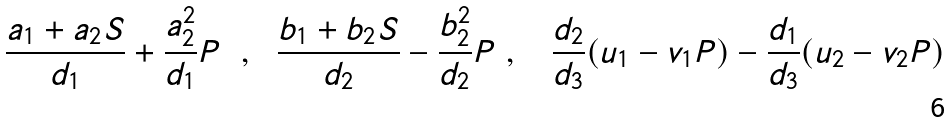<formula> <loc_0><loc_0><loc_500><loc_500>\frac { a _ { 1 } + a _ { 2 } S } { d _ { 1 } } + \frac { a _ { 2 } ^ { 2 } } { d _ { 1 } } P \text { \ } , \text { \ } \frac { b _ { 1 } + b _ { 2 } S } { d _ { 2 } } - \frac { b _ { 2 } ^ { 2 } } { d _ { 2 } } P \text { } , \text { \ \ } \frac { d _ { 2 } } { d _ { 3 } } ( u _ { 1 } - v _ { 1 } P ) - \frac { d _ { 1 } } { d _ { 3 } } ( u _ { 2 } - v _ { 2 } P )</formula> 